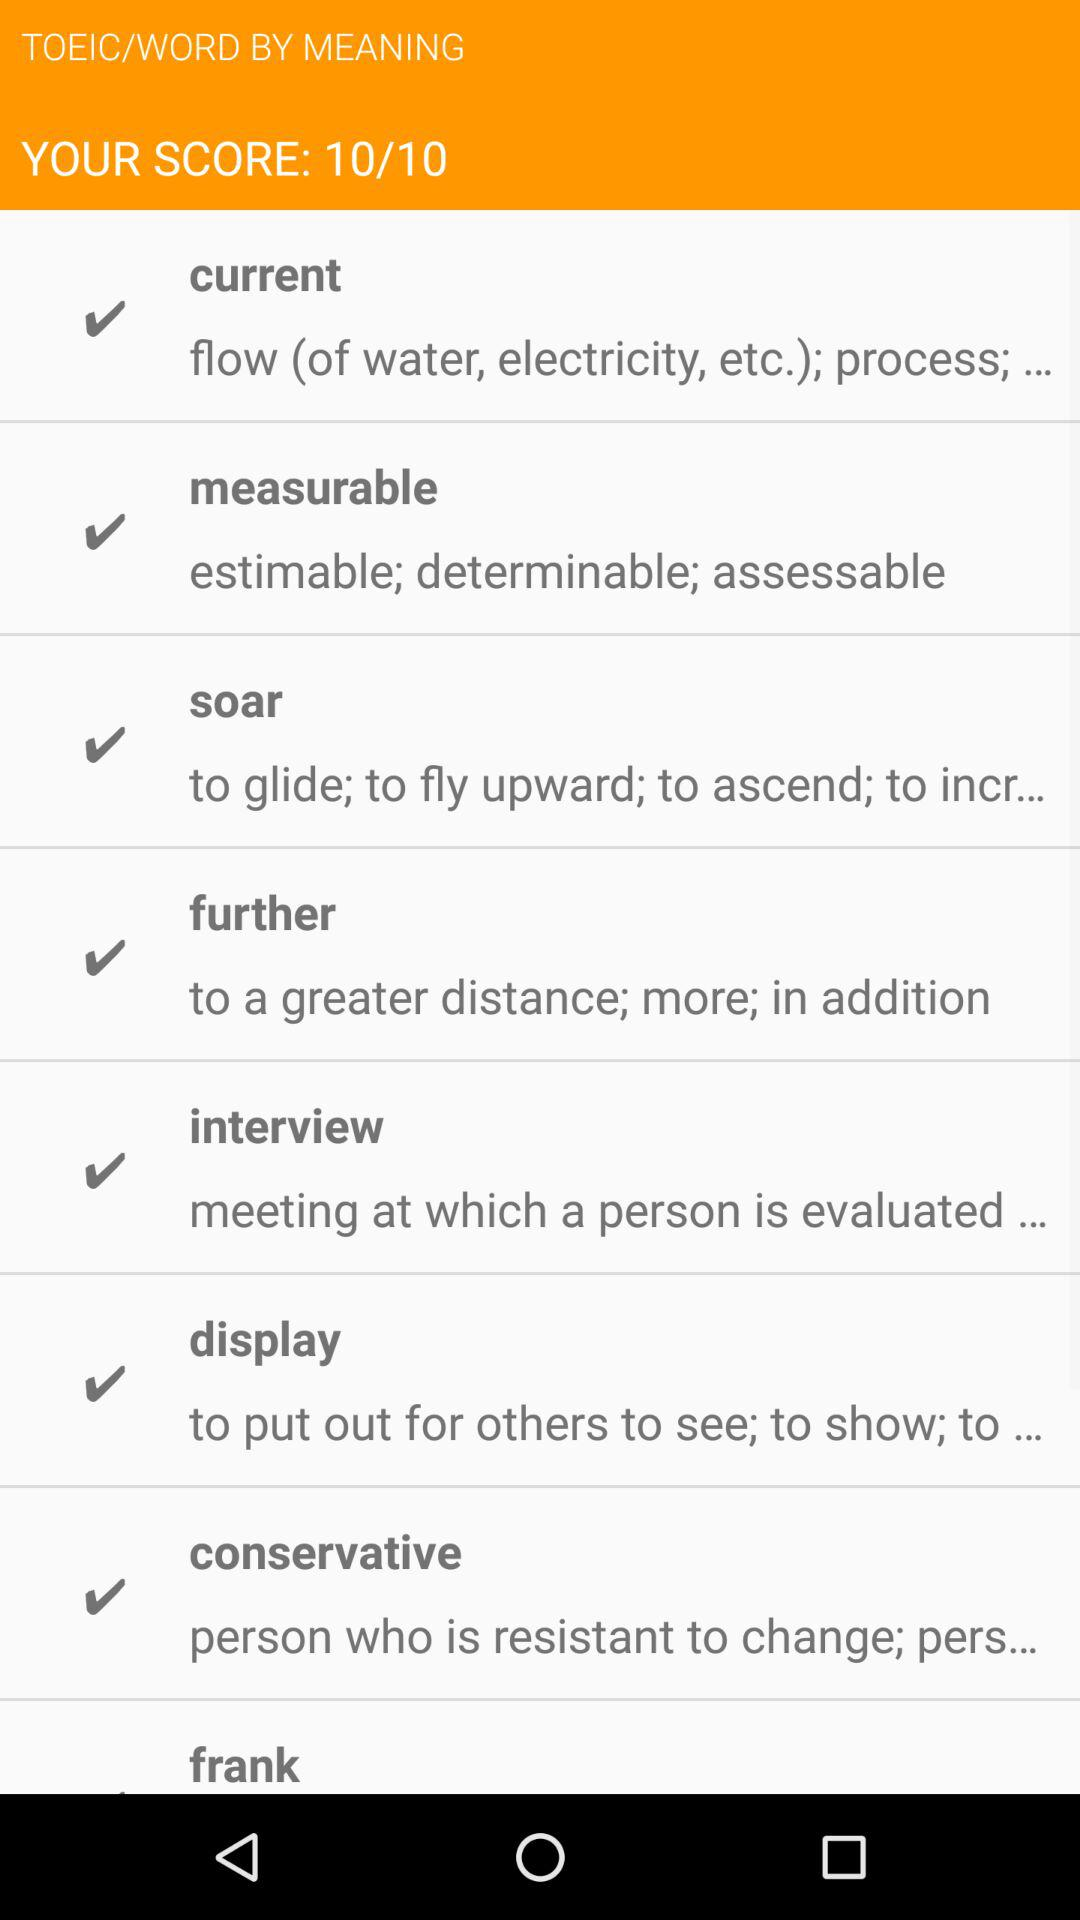What is the score? The score is 10 out of 10. 